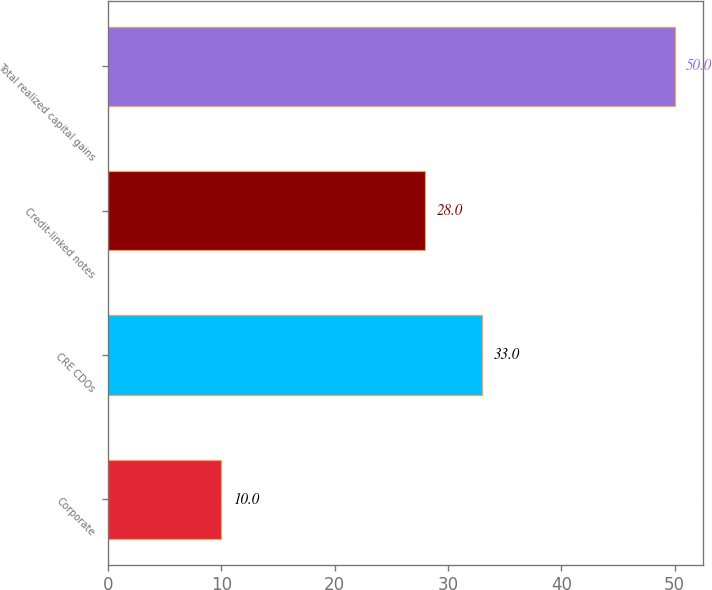<chart> <loc_0><loc_0><loc_500><loc_500><bar_chart><fcel>Corporate<fcel>CRE CDOs<fcel>Credit-linked notes<fcel>Total realized capital gains<nl><fcel>10<fcel>33<fcel>28<fcel>50<nl></chart> 